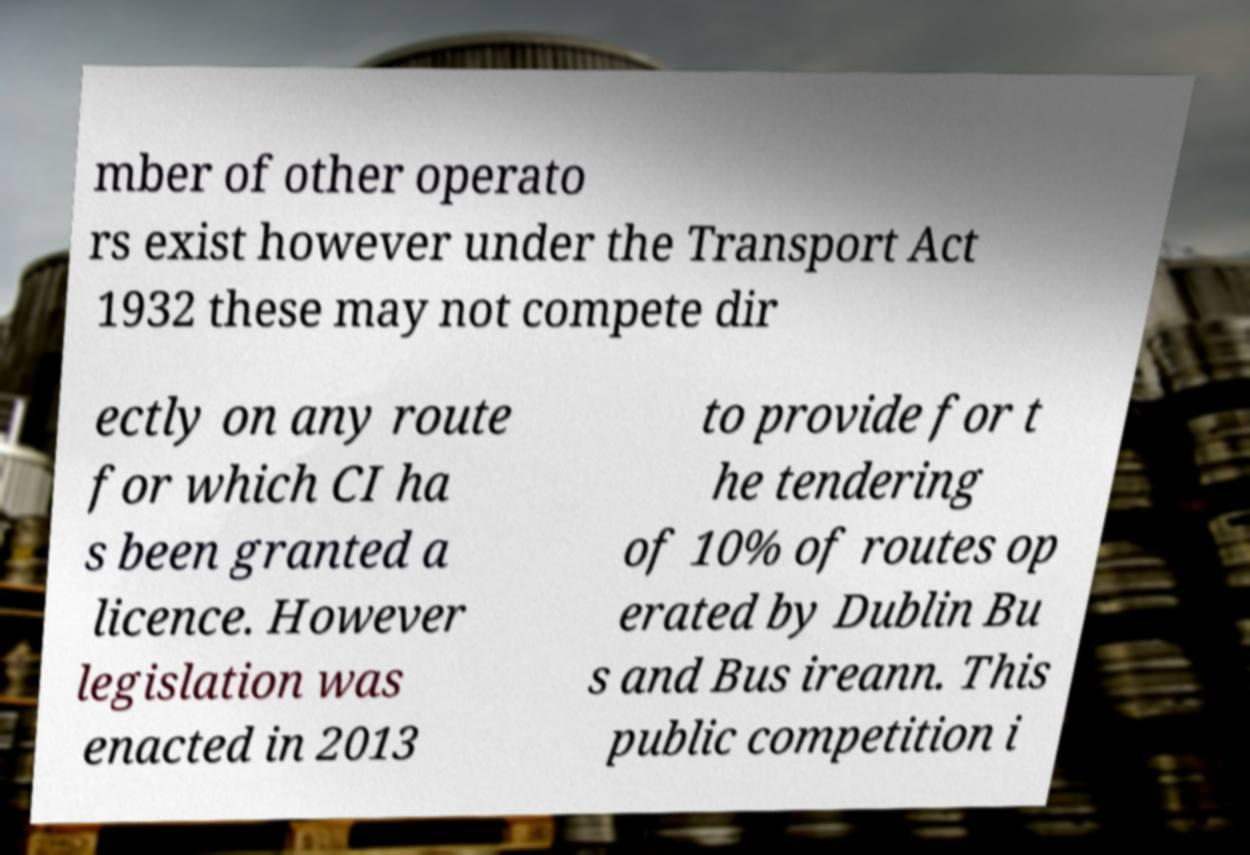Could you extract and type out the text from this image? mber of other operato rs exist however under the Transport Act 1932 these may not compete dir ectly on any route for which CI ha s been granted a licence. However legislation was enacted in 2013 to provide for t he tendering of 10% of routes op erated by Dublin Bu s and Bus ireann. This public competition i 